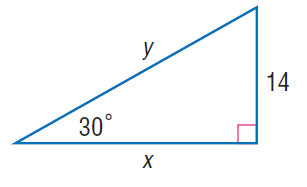Answer the mathemtical geometry problem and directly provide the correct option letter.
Question: Find y.
Choices: A: 12 B: 23 C: 28 D: 43 C 